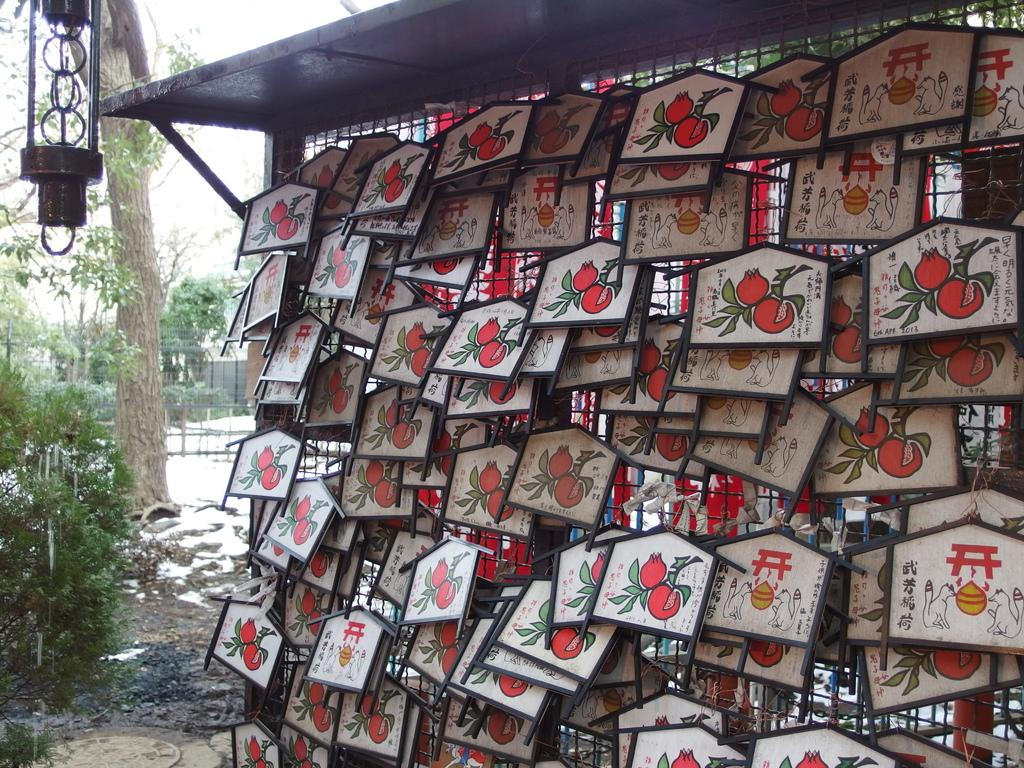What type of wall is featured in the image? There is a mesh wall in the image. What is attached to the mesh wall? Boards are hanging on the mesh wall. What can be seen on the boards? Images are present on the boards. What type of vegetation is on the right side of the image? There are trees on the right side of the image. What is visible at the top of the image? There is an object visible at the top of the image. Can you tell me how many birds are in the flock that is flying over the mesh wall in the image? There is no flock of birds present in the image; it only features a mesh wall with boards and images. 